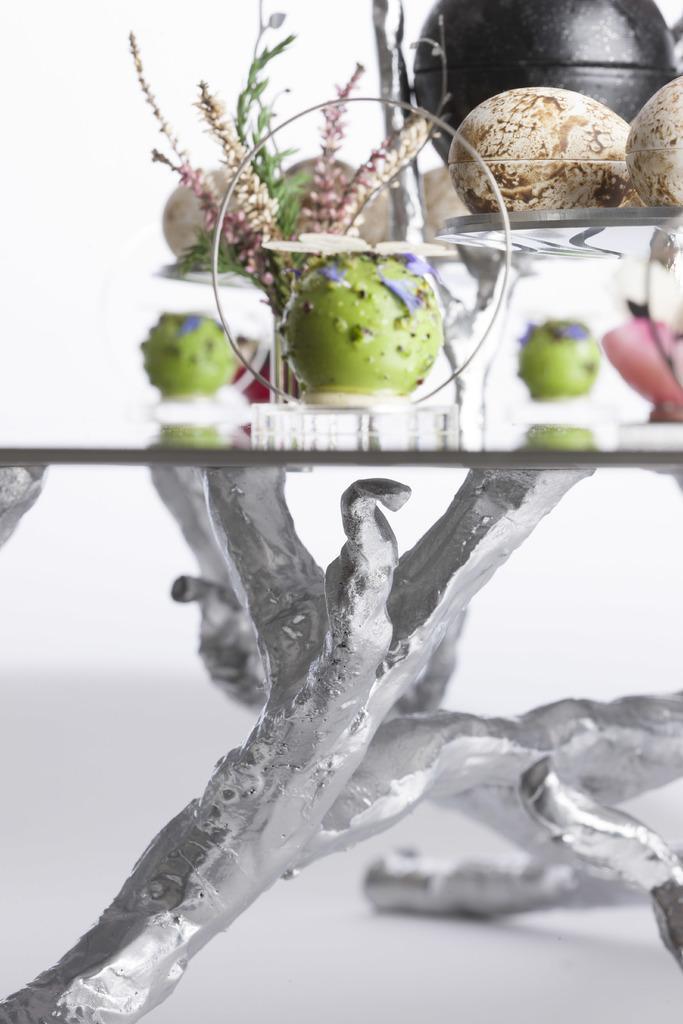Could you give a brief overview of what you see in this image? This is a collage image. At the bottom the image is black and white and we can see a stand. At the top of the image we can see a plant and some other objects. 